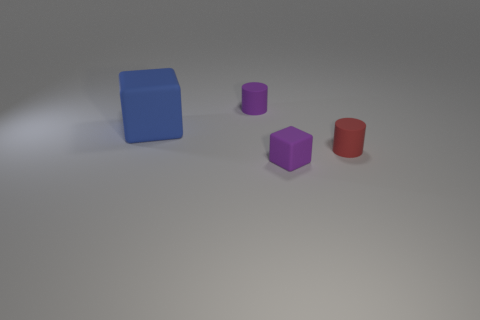What is the size of the purple object that is the same shape as the small red object?
Provide a succinct answer. Small. What number of blocks are the same size as the red cylinder?
Keep it short and to the point. 1. What is the material of the red cylinder?
Keep it short and to the point. Rubber. Are there any tiny purple objects behind the big blue block?
Make the answer very short. Yes. What is the size of the red thing that is made of the same material as the tiny purple cube?
Offer a terse response. Small. How many matte things are the same color as the tiny block?
Provide a short and direct response. 1. Is the number of matte cylinders in front of the purple cube less than the number of small purple cylinders that are on the left side of the tiny purple cylinder?
Your response must be concise. No. There is a block that is behind the small red matte thing; how big is it?
Provide a short and direct response. Large. The cylinder that is the same color as the small matte cube is what size?
Offer a terse response. Small. Is there a tiny purple cube that has the same material as the large blue thing?
Provide a short and direct response. Yes. 